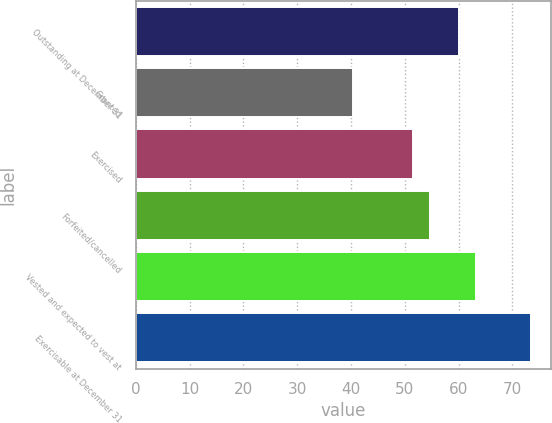<chart> <loc_0><loc_0><loc_500><loc_500><bar_chart><fcel>Outstanding at December 31<fcel>Granted<fcel>Exercised<fcel>Forfeited/cancelled<fcel>Vested and expected to vest at<fcel>Exercisable at December 31<nl><fcel>60.08<fcel>40.43<fcel>51.5<fcel>54.72<fcel>63.3<fcel>73.5<nl></chart> 